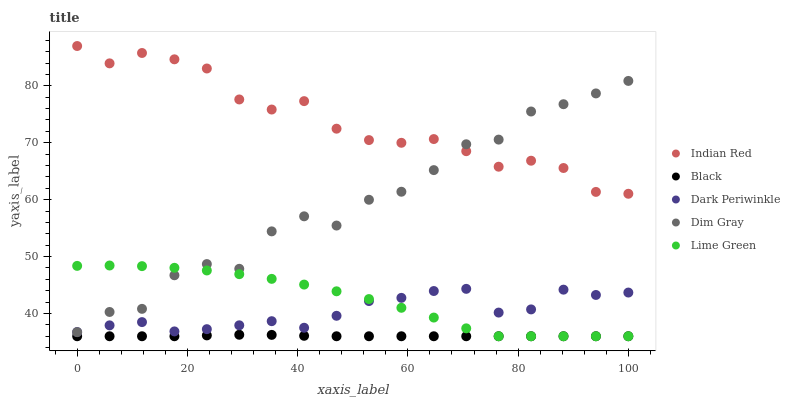Does Black have the minimum area under the curve?
Answer yes or no. Yes. Does Indian Red have the maximum area under the curve?
Answer yes or no. Yes. Does Dim Gray have the minimum area under the curve?
Answer yes or no. No. Does Dim Gray have the maximum area under the curve?
Answer yes or no. No. Is Black the smoothest?
Answer yes or no. Yes. Is Dim Gray the roughest?
Answer yes or no. Yes. Is Dim Gray the smoothest?
Answer yes or no. No. Is Black the roughest?
Answer yes or no. No. Does Lime Green have the lowest value?
Answer yes or no. Yes. Does Dim Gray have the lowest value?
Answer yes or no. No. Does Indian Red have the highest value?
Answer yes or no. Yes. Does Dim Gray have the highest value?
Answer yes or no. No. Is Dark Periwinkle less than Indian Red?
Answer yes or no. Yes. Is Indian Red greater than Black?
Answer yes or no. Yes. Does Dim Gray intersect Dark Periwinkle?
Answer yes or no. Yes. Is Dim Gray less than Dark Periwinkle?
Answer yes or no. No. Is Dim Gray greater than Dark Periwinkle?
Answer yes or no. No. Does Dark Periwinkle intersect Indian Red?
Answer yes or no. No. 